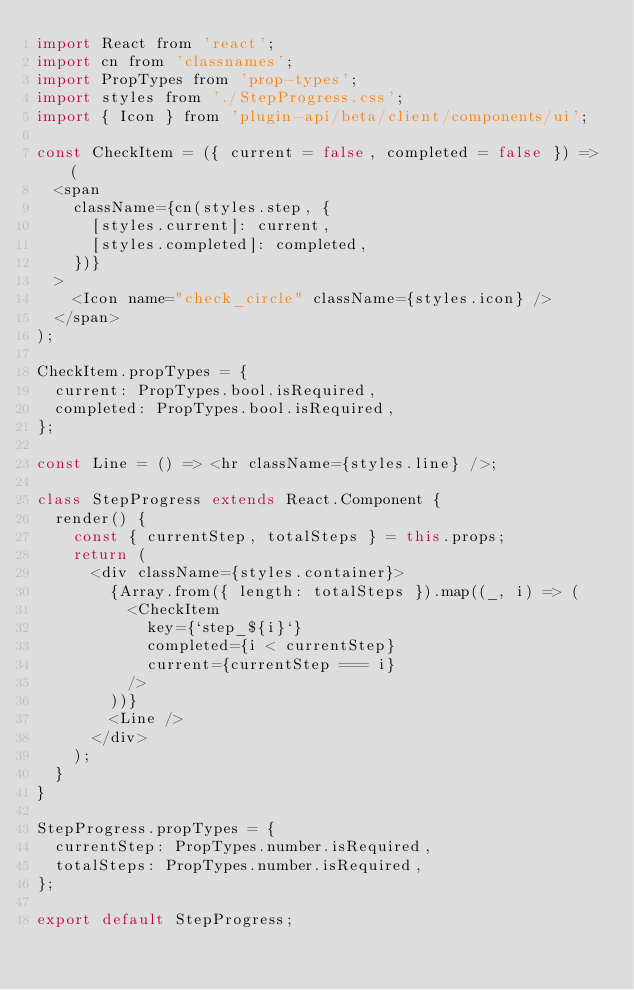Convert code to text. <code><loc_0><loc_0><loc_500><loc_500><_JavaScript_>import React from 'react';
import cn from 'classnames';
import PropTypes from 'prop-types';
import styles from './StepProgress.css';
import { Icon } from 'plugin-api/beta/client/components/ui';

const CheckItem = ({ current = false, completed = false }) => (
  <span
    className={cn(styles.step, {
      [styles.current]: current,
      [styles.completed]: completed,
    })}
  >
    <Icon name="check_circle" className={styles.icon} />
  </span>
);

CheckItem.propTypes = {
  current: PropTypes.bool.isRequired,
  completed: PropTypes.bool.isRequired,
};

const Line = () => <hr className={styles.line} />;

class StepProgress extends React.Component {
  render() {
    const { currentStep, totalSteps } = this.props;
    return (
      <div className={styles.container}>
        {Array.from({ length: totalSteps }).map((_, i) => (
          <CheckItem
            key={`step_${i}`}
            completed={i < currentStep}
            current={currentStep === i}
          />
        ))}
        <Line />
      </div>
    );
  }
}

StepProgress.propTypes = {
  currentStep: PropTypes.number.isRequired,
  totalSteps: PropTypes.number.isRequired,
};

export default StepProgress;
</code> 